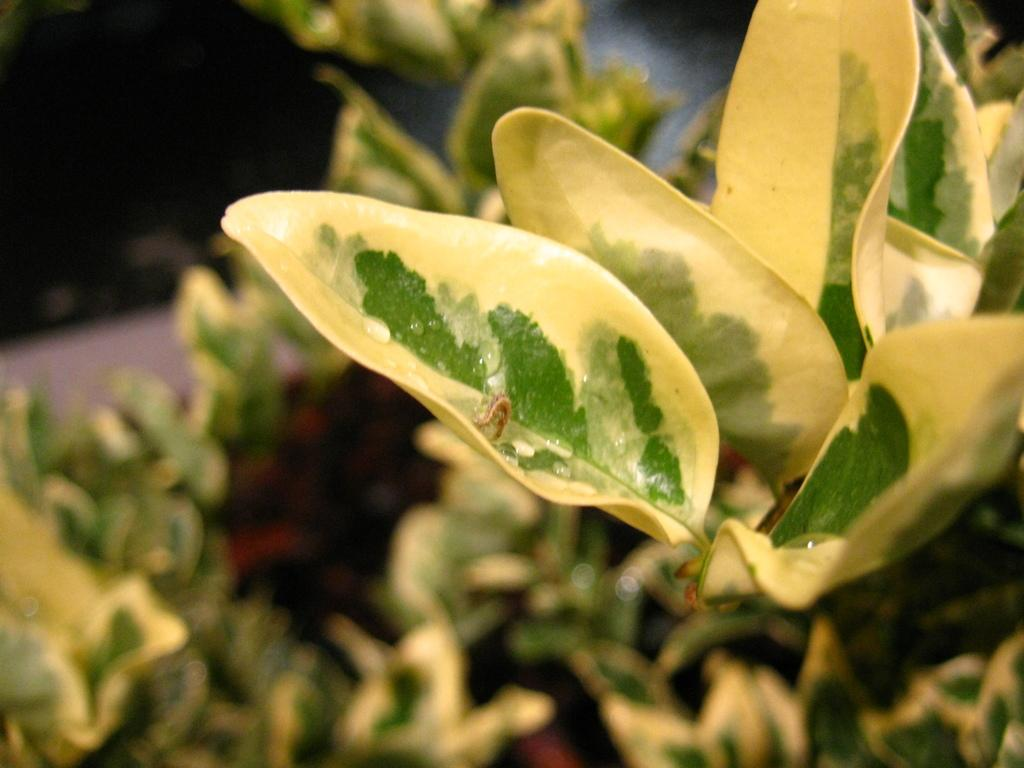What colors are the leaves in the image? The leaves in the image are green and yellow. Can you describe the background of the image? The background of the image is blurred. Is there a stranger in space visible in the image? No, there is no stranger in space visible in the image. The image only contains green and yellow leaves, and the background is blurred. 